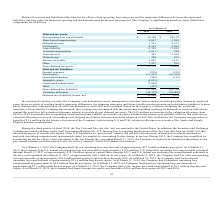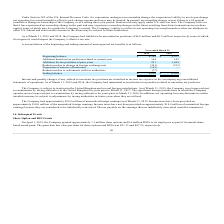According to Mimecast Limited's financial document, What was the increase in the valuation allowance from 2018 to 2019? According to the financial document, $4.3 million. The relevant text states: "against its worldwide net deferred tax assets. The $4.3 million net increase in the valuation allowance from 2018 to 2019 is primarily due to operating losses incur..." Also, What was the tax benefit recognized by the company? According to the financial document, $1.0 million. The relevant text states: "addition, the Company recognized a tax benefit of $1.0 million for the release of a portion of the Company’s pre-existing U.S. and U.K. valuation allowances as a r..." Also, What was the Net operating loss carryforwards in 2019 and 2018 respectively? The document shows two values: $35,120 and $24,159. From the document: "Net operating loss carryforwards $ 35,120 $ 24,159 Net operating loss carryforwards $ 35,120 $ 24,159..." Also, can you calculate: What was the change in the Net operating loss carryforwards from 2018 to 2019? Based on the calculation: 35,120 - 24,159, the result is 10961. This is based on the information: "Net operating loss carryforwards $ 35,120 $ 24,159 Net operating loss carryforwards $ 35,120 $ 24,159..." The key data points involved are: 24,159, 35,120. Also, can you calculate: What is the average Share-based compensation for 2018 and 2019? To answer this question, I need to perform calculations using the financial data. The calculation is: (5,687 + 2,760) / 2, which equals 4223.5. This is based on the information: "Share-based compensation 5,687 2,760 Share-based compensation 5,687 2,760..." The key data points involved are: 2,760, 5,687. Additionally, In which year was Deferred revenue less than 2,000? According to the financial document, 2019. The relevant text states: "2019 2018..." 